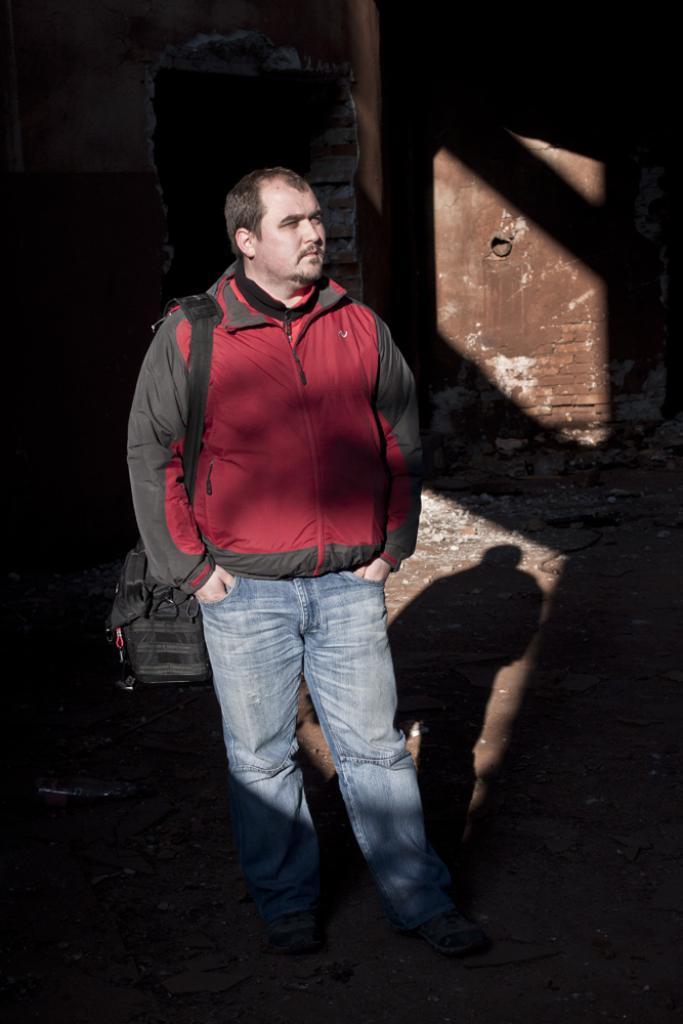Can you describe this image briefly? In this picture we can see a man standing here, he is carrying a bag, in the background there is a wall, we can see shadow here. 